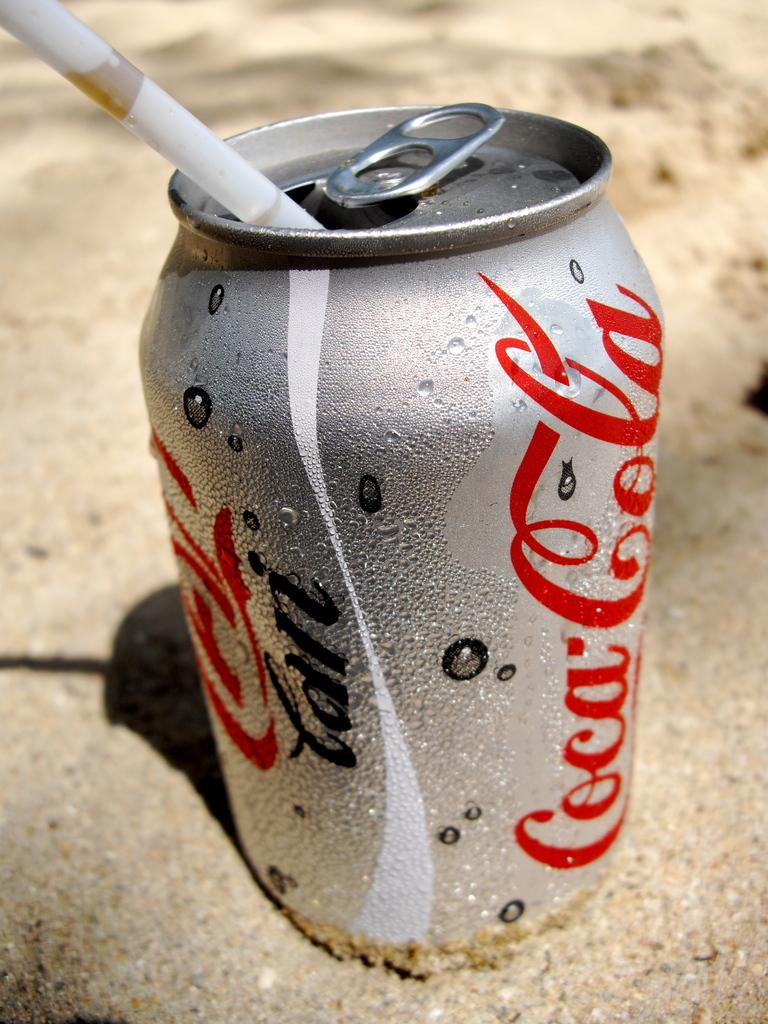<image>
Offer a succinct explanation of the picture presented. The diet Coca Cola can has a straw sticking out of the opening. 